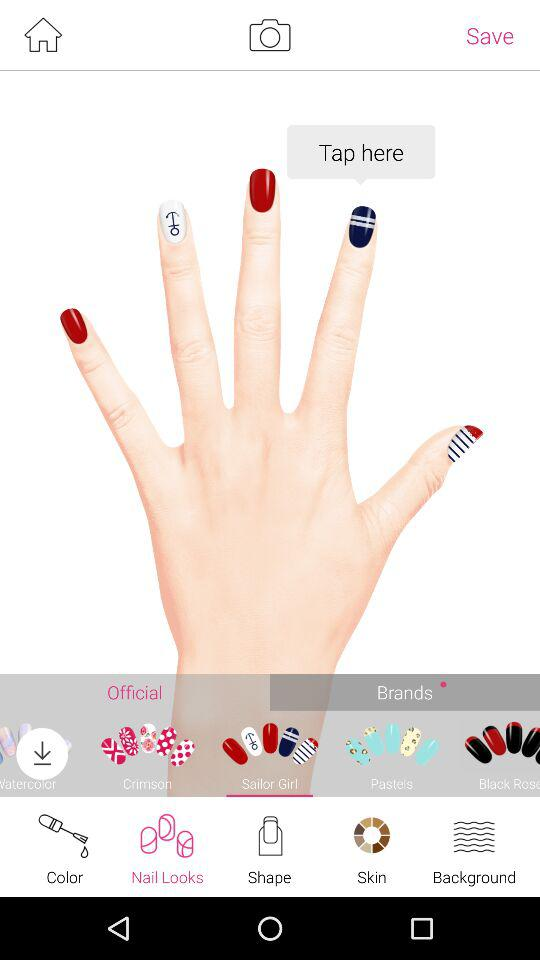Which nail look is selected? The selected nail look is "Sailor Girl". 